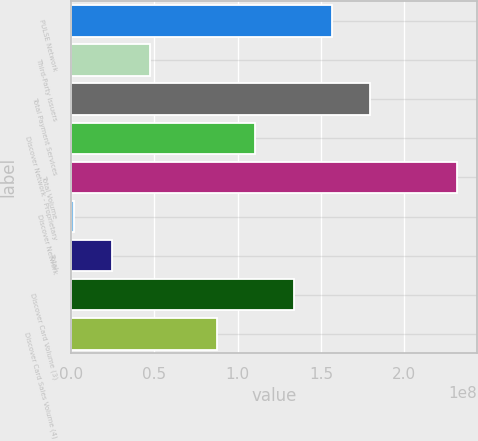<chart> <loc_0><loc_0><loc_500><loc_500><bar_chart><fcel>PULSE Network<fcel>Third-Party Issuers<fcel>Total Payment Services<fcel>Discover Network - Proprietary<fcel>Total Volume<fcel>Discover Network<fcel>Total<fcel>Discover Card Volume (3)<fcel>Discover Card Sales Volume (4)<nl><fcel>1.56557e+08<fcel>4.75783e+07<fcel>1.79589e+08<fcel>1.10493e+08<fcel>2.31836e+08<fcel>1.51396e+06<fcel>2.45461e+07<fcel>1.33525e+08<fcel>8.74606e+07<nl></chart> 